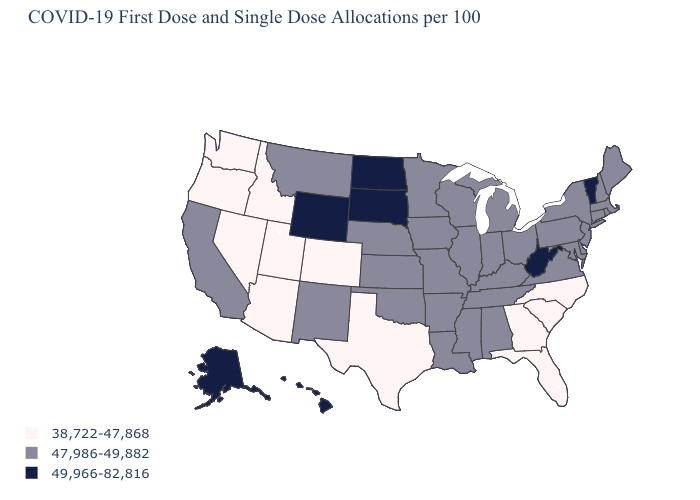Does Vermont have the highest value in the Northeast?
Keep it brief. Yes. What is the highest value in the USA?
Keep it brief. 49,966-82,816. Does Tennessee have the same value as New Mexico?
Answer briefly. Yes. Which states hav the highest value in the West?
Concise answer only. Alaska, Hawaii, Wyoming. Does New Hampshire have a lower value than Vermont?
Concise answer only. Yes. Does the map have missing data?
Keep it brief. No. Does Utah have the lowest value in the USA?
Be succinct. Yes. Name the states that have a value in the range 47,986-49,882?
Keep it brief. Alabama, Arkansas, California, Connecticut, Delaware, Illinois, Indiana, Iowa, Kansas, Kentucky, Louisiana, Maine, Maryland, Massachusetts, Michigan, Minnesota, Mississippi, Missouri, Montana, Nebraska, New Hampshire, New Jersey, New Mexico, New York, Ohio, Oklahoma, Pennsylvania, Rhode Island, Tennessee, Virginia, Wisconsin. What is the highest value in states that border Washington?
Be succinct. 38,722-47,868. Which states have the lowest value in the MidWest?
Be succinct. Illinois, Indiana, Iowa, Kansas, Michigan, Minnesota, Missouri, Nebraska, Ohio, Wisconsin. What is the value of Missouri?
Write a very short answer. 47,986-49,882. What is the value of Minnesota?
Quick response, please. 47,986-49,882. What is the lowest value in the South?
Be succinct. 38,722-47,868. Name the states that have a value in the range 47,986-49,882?
Quick response, please. Alabama, Arkansas, California, Connecticut, Delaware, Illinois, Indiana, Iowa, Kansas, Kentucky, Louisiana, Maine, Maryland, Massachusetts, Michigan, Minnesota, Mississippi, Missouri, Montana, Nebraska, New Hampshire, New Jersey, New Mexico, New York, Ohio, Oklahoma, Pennsylvania, Rhode Island, Tennessee, Virginia, Wisconsin. What is the lowest value in the USA?
Quick response, please. 38,722-47,868. 